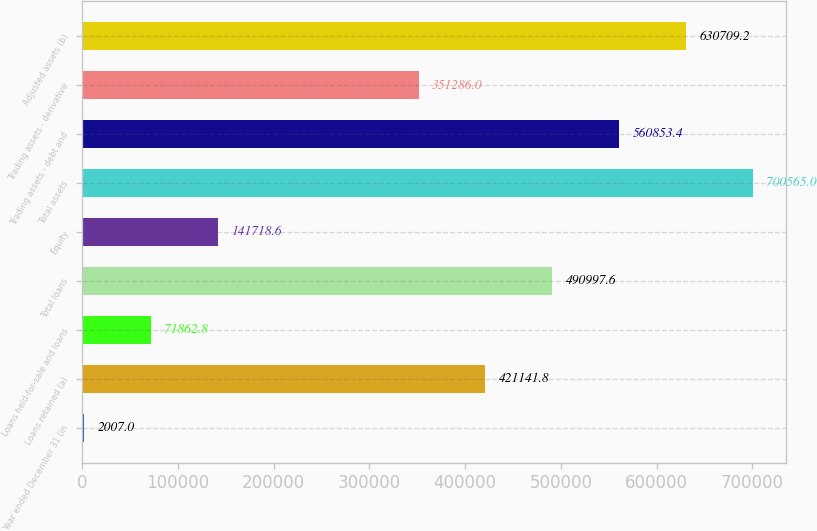<chart> <loc_0><loc_0><loc_500><loc_500><bar_chart><fcel>Year ended December 31 (in<fcel>Loans retained (a)<fcel>Loans held-for-sale and loans<fcel>Total loans<fcel>Equity<fcel>Total assets<fcel>Trading assets - debt and<fcel>Trading assets - derivative<fcel>Adjusted assets (b)<nl><fcel>2007<fcel>421142<fcel>71862.8<fcel>490998<fcel>141719<fcel>700565<fcel>560853<fcel>351286<fcel>630709<nl></chart> 